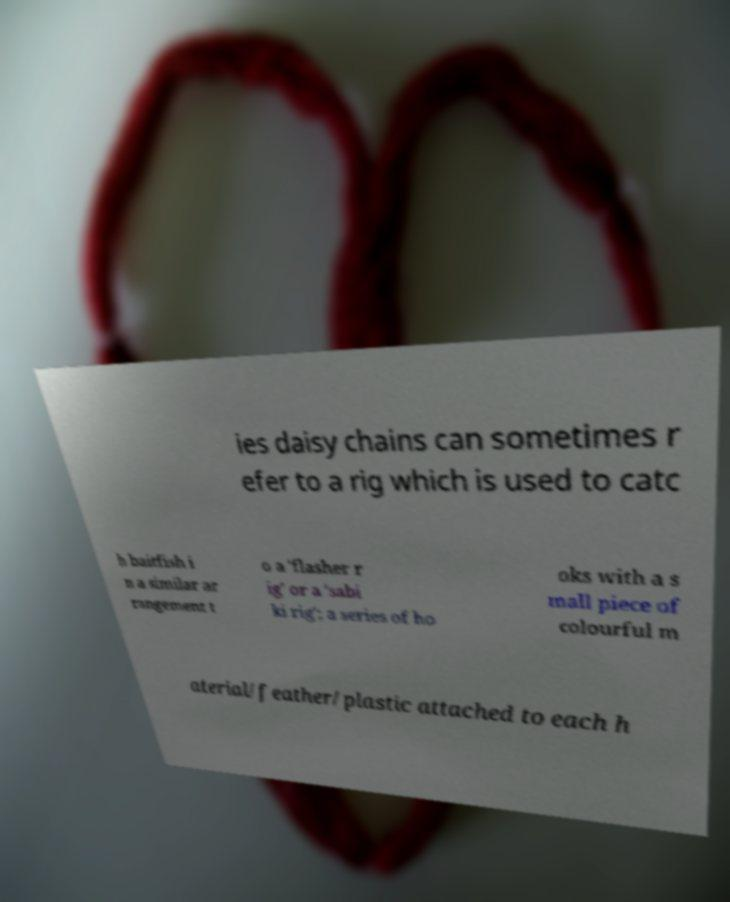Please identify and transcribe the text found in this image. ies daisy chains can sometimes r efer to a rig which is used to catc h baitfish i n a similar ar rangement t o a 'flasher r ig' or a 'sabi ki rig'; a series of ho oks with a s mall piece of colourful m aterial/feather/plastic attached to each h 